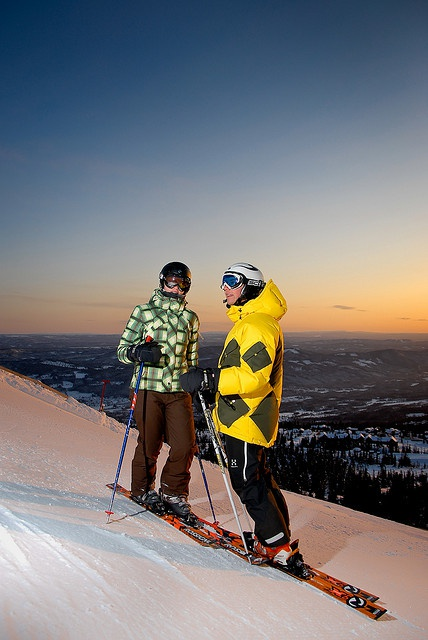Describe the objects in this image and their specific colors. I can see people in navy, black, gold, orange, and darkgreen tones, people in navy, black, maroon, gray, and darkgray tones, skis in navy, black, brown, and darkgray tones, and skis in navy, black, maroon, brown, and gray tones in this image. 